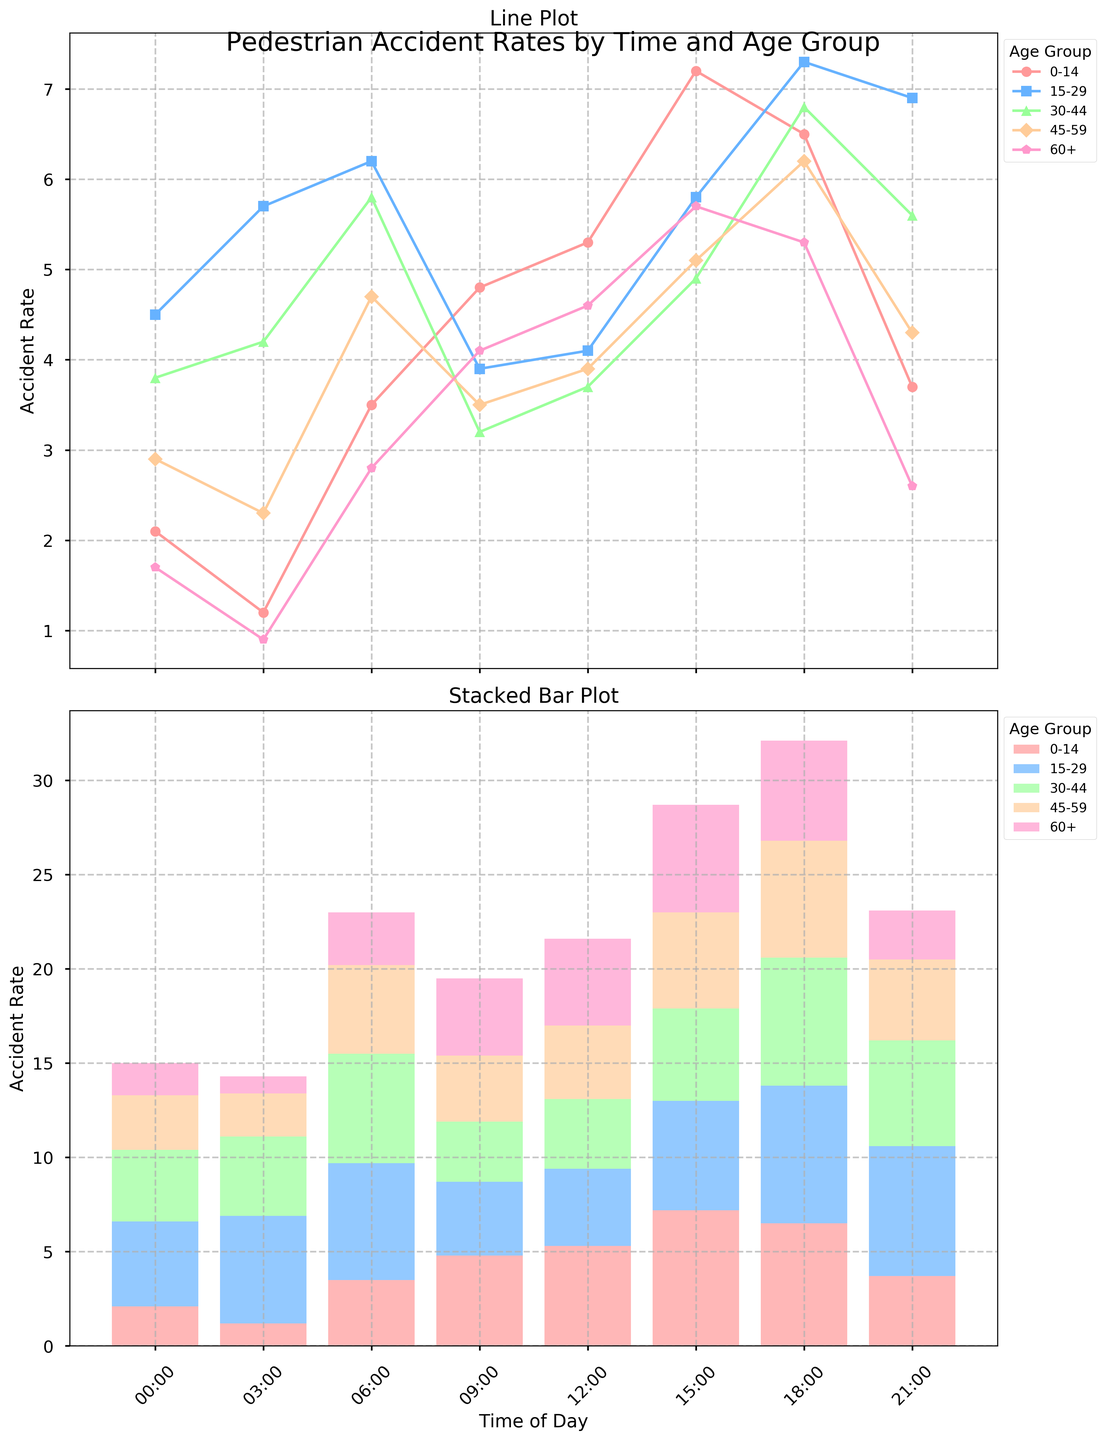Which age group has the highest accident rate at 6:00? To find the highest accident rate at 6:00, we compare the values for each age group: 3.5 (0-14), 6.2 (15-29), 5.8 (30-44), 4.7 (45-59), and 2.8 (60+). The highest value is 6.2 for the 15-29 age group.
Answer: 15-29 What is the difference in accident rates between the 0-14 and 45-59 age groups at 18:00? Check the accident rates for 0-14 and 45-59 at 18:00. They are 6.5 and 6.2, respectively. The difference is 6.5 - 6.2.
Answer: 0.3 At what time does the 30-44 age group experience its lowest accident rate? Look for the lowest value in the 30-44 age group across all times: 3.8, 4.2, 5.8, 3.2, 3.7, 4.9, 6.8, 5.6. The lowest value is 3.2 at 09:00.
Answer: 09:00 During which time period is the total accident rate the highest across all age groups? Sum the accident rates for all age groups at each time: at 00:00 it is 15.0, at 03:00 it is 14.3, at 06:00 it is 23.0, at 09:00 it is 19.5, at 12:00 it is 21.6, at 15:00 it is 28.7, at 18:00 it is 31.6, and at 21:00 it is 23.1. The highest total is 31.6 at 18:00.
Answer: 18:00 Which age group predominantly contributes to the accident rate at 03:00? Compare the accident rates of different age groups at 03:00: 1.2 (0-14), 5.7 (15-29), 4.2 (30-44), 2.3 (45-59), and 0.9 (60+). The 15-29 age group has the highest rate at 5.7, indicating the major contribution.
Answer: 15-29 How does the accident rate for the 60+ age group at 15:00 compare to the same group's rate at 21:00? Check the accident rate for the 60+ age group at 15:00 and 21:00. They are 5.7 and 2.6, respectively. 5.7 is greater than 2.6.
Answer: Higher at 15:00 What is the combined accident rate for the 0-14 and 60+ age groups at 00:00? Add the accident rates of the 0-14 and 60+ age groups at 00:00. They are 2.1 and 1.7, respectively. The sum is 2.1 + 1.7.
Answer: 3.8 Which age group shows the most fluctuation in accident rates throughout the day? Track the range of accident rates for each age group by subtracting the minimum value from the maximum value: 0-14 (7.2-1.2=6.0), 15-29 (7.3-3.9=3.4), 30-44 (6.8-3.2=3.6), 45-59 (6.2-2.3=3.9), and 60+ (5.7-0.9=4.8). The 0-14 group has the largest fluctuation of 6.0.
Answer: 0-14 At what time does the 15-29 age group show its highest accident rate and what is the value? Determine the highest accident rate for the 15-29 age group: 4.5, 5.7, 6.2, 3.9, 4.1, 5.8, 7.3, and 6.9. The highest value is 7.3 at 18:00.
Answer: 18:00, 7.3 